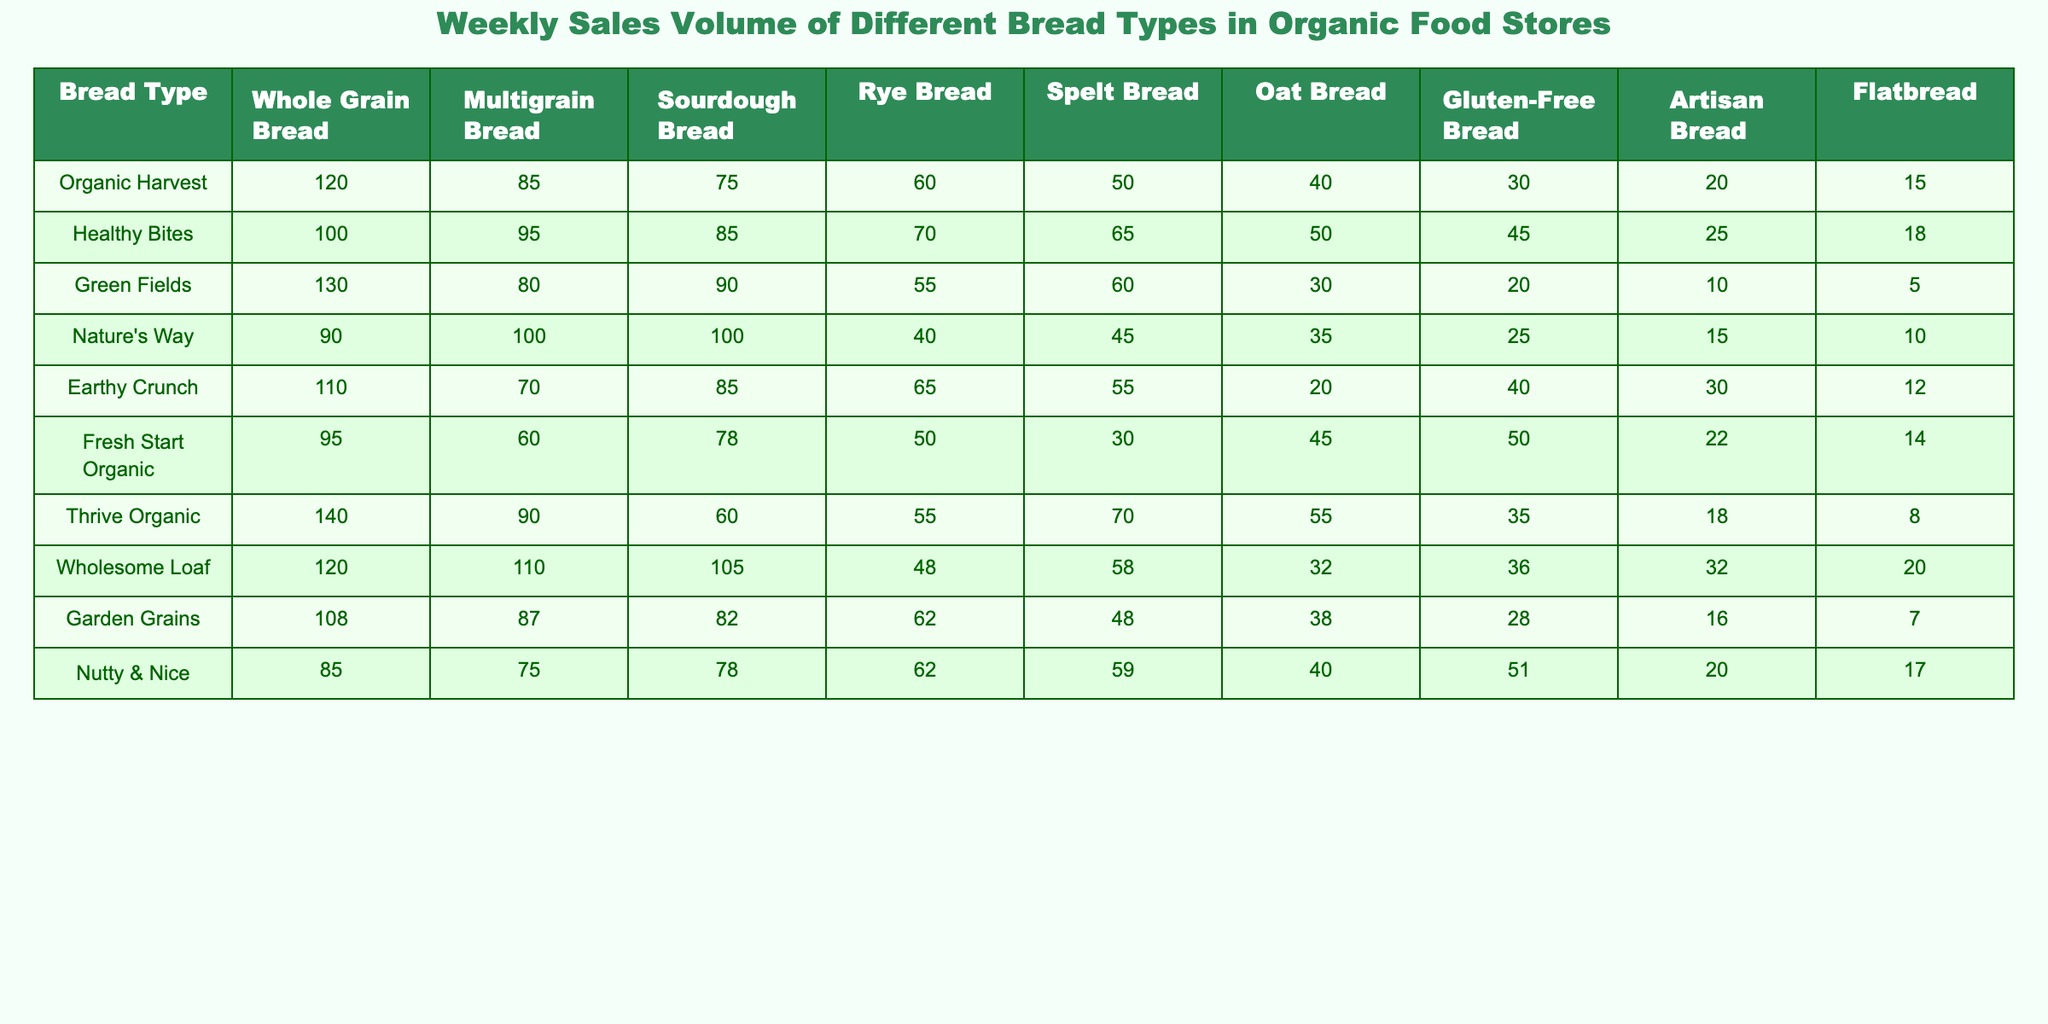What is the highest selling bread type overall? To find the highest selling bread type overall, we look at the total sales volume for each type of bread across all stores. The maximum sales value corresponds to Whole Grain Bread with a total of 1,046 (120+100+130+90+110+95+140+120+108+85)
Answer: Whole Grain Bread Which store sold the most Sourdough Bread? Looking at the Sourdough Bread column, we can see the highest sales value belongs to Wholesome Loaf with 105 units.
Answer: Wholesome Loaf What is the average sales volume for Gluten-Free Bread across all stores? The sales volumes for Gluten-Free Bread are: 30, 45, 20, 25, 40, 50, 35, 36, 28, and 51. Summing these values gives  30 + 45 + 20 + 25 + 40 + 50 + 35 + 36 + 28 + 51 =  410. There are 10 entries, so the average is 410 / 10 = 41.
Answer: 41 Which bread types sold more than 70 units in Nature's Way? In Nature's Way, the bread types that sold more than 70 units are Whole Grain Bread (90), Multigrain Bread (100), and Sourdough Bread (100).
Answer: Whole Grain, Multigrain, Sourdough How much more did Healthy Bites sell in Multigrain Bread compared to Flatbread? Healthy Bites sold 95 units of Multigrain Bread and 18 units of Flatbread. The difference is 95 - 18 = 77 units.
Answer: 77 Which store has the lowest sales volume for Rye Bread, and what is the amount? Looking at the Rye Bread column, Green Fields has the lowest sales with 55 units.
Answer: Green Fields, 55 If we combine the sales of Whole Grain and Spelt Bread from all stores, which one has a higher total? Total sales for Whole Grain Bread are 1,046, and for Spelt Bread are 505 (50 + 65 + 60 + 45 + 55 + 30 + 70 + 58 + 48 + 59). Since 1,046 > 505, Whole Grain Bread has a higher total.
Answer: Whole Grain Bread Was the sales volume for Artisan Bread across all stores higher than 300 units? Summing the sales for Artisan Bread, we get 20 + 25 + 10 + 15 + 30 + 22 + 18 + 32 + 16 + 20 = 208. Thus, the total sales volume is not higher than 300.
Answer: No What is the difference in sales volume for Oat Bread between the highest and lowest selling stores? The highest selling Oat Bread comes from Healthy Bites with 50 units and the lowest from Nature's Way with 35 units. The difference is 50 - 35 = 15 units.
Answer: 15 Which type of bread had the second highest sales in Fresh Start Organic? In Fresh Start Organic, the sales for different types of bread are: Whole Grain (95), Multigrain (60), Sourdough (78), Rye (50), Spelt (30), Oat (45), Gluten-Free (50), Artisan (22), and Flatbread (14). The second highest is Sourdough with 78 units.
Answer: Sourdough 